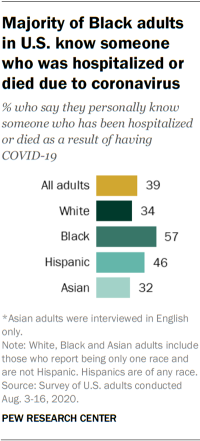Outline some significant characteristics in this image. The yellow bar has a value of 39. The median and the largest value of a dataset sum to 96. 